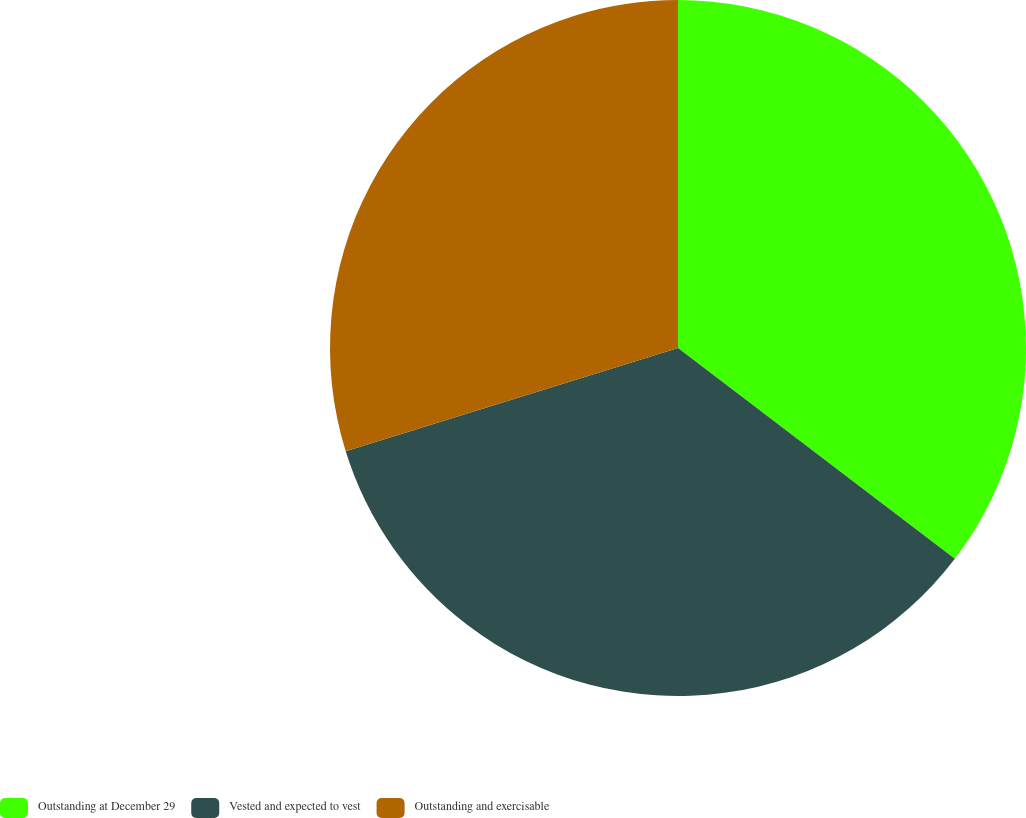<chart> <loc_0><loc_0><loc_500><loc_500><pie_chart><fcel>Outstanding at December 29<fcel>Vested and expected to vest<fcel>Outstanding and exercisable<nl><fcel>35.36%<fcel>34.84%<fcel>29.8%<nl></chart> 